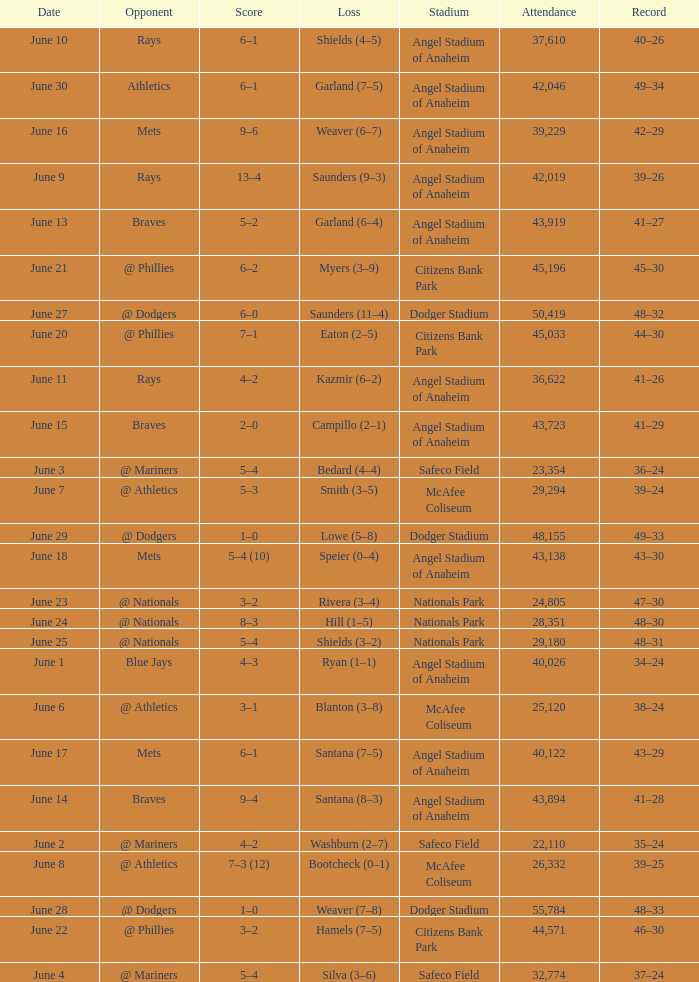What was the score of the game against the Braves with a record of 41–27? 5–2. 